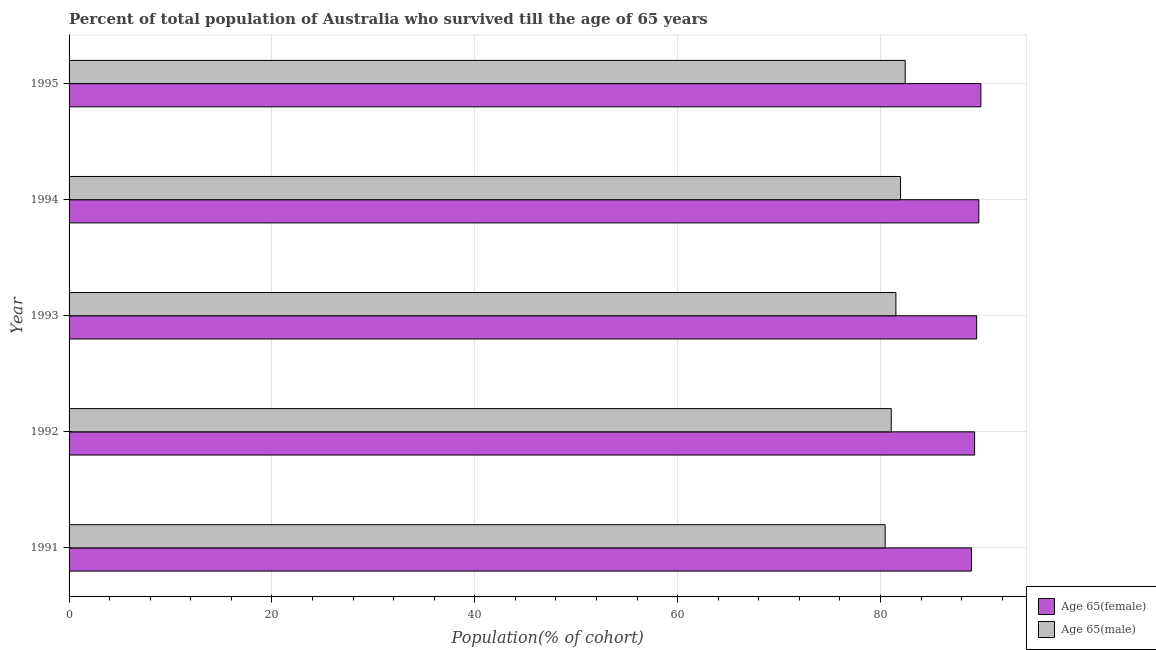How many groups of bars are there?
Provide a short and direct response. 5. Are the number of bars per tick equal to the number of legend labels?
Provide a succinct answer. Yes. Are the number of bars on each tick of the Y-axis equal?
Ensure brevity in your answer.  Yes. What is the label of the 3rd group of bars from the top?
Your answer should be very brief. 1993. What is the percentage of male population who survived till age of 65 in 1993?
Provide a short and direct response. 81.52. Across all years, what is the maximum percentage of female population who survived till age of 65?
Keep it short and to the point. 89.9. Across all years, what is the minimum percentage of male population who survived till age of 65?
Your response must be concise. 80.46. What is the total percentage of male population who survived till age of 65 in the graph?
Ensure brevity in your answer.  407.48. What is the difference between the percentage of male population who survived till age of 65 in 1991 and that in 1994?
Offer a terse response. -1.52. What is the difference between the percentage of female population who survived till age of 65 in 1994 and the percentage of male population who survived till age of 65 in 1991?
Provide a short and direct response. 9.23. What is the average percentage of female population who survived till age of 65 per year?
Your answer should be compact. 89.47. In the year 1991, what is the difference between the percentage of female population who survived till age of 65 and percentage of male population who survived till age of 65?
Provide a short and direct response. 8.5. What is the ratio of the percentage of female population who survived till age of 65 in 1992 to that in 1994?
Give a very brief answer. 0.99. What is the difference between the highest and the second highest percentage of female population who survived till age of 65?
Your answer should be very brief. 0.21. What is the difference between the highest and the lowest percentage of male population who survived till age of 65?
Give a very brief answer. 1.98. Is the sum of the percentage of female population who survived till age of 65 in 1991 and 1995 greater than the maximum percentage of male population who survived till age of 65 across all years?
Offer a terse response. Yes. What does the 2nd bar from the top in 1991 represents?
Provide a succinct answer. Age 65(female). What does the 1st bar from the bottom in 1993 represents?
Provide a short and direct response. Age 65(female). How many bars are there?
Keep it short and to the point. 10. Are all the bars in the graph horizontal?
Ensure brevity in your answer.  Yes. What is the difference between two consecutive major ticks on the X-axis?
Your answer should be very brief. 20. Are the values on the major ticks of X-axis written in scientific E-notation?
Give a very brief answer. No. Does the graph contain any zero values?
Make the answer very short. No. Where does the legend appear in the graph?
Provide a short and direct response. Bottom right. How are the legend labels stacked?
Offer a terse response. Vertical. What is the title of the graph?
Your answer should be very brief. Percent of total population of Australia who survived till the age of 65 years. What is the label or title of the X-axis?
Provide a short and direct response. Population(% of cohort). What is the Population(% of cohort) in Age 65(female) in 1991?
Keep it short and to the point. 88.97. What is the Population(% of cohort) in Age 65(male) in 1991?
Give a very brief answer. 80.46. What is the Population(% of cohort) in Age 65(female) in 1992?
Offer a terse response. 89.28. What is the Population(% of cohort) of Age 65(male) in 1992?
Keep it short and to the point. 81.07. What is the Population(% of cohort) in Age 65(female) in 1993?
Offer a terse response. 89.49. What is the Population(% of cohort) of Age 65(male) in 1993?
Your response must be concise. 81.52. What is the Population(% of cohort) in Age 65(female) in 1994?
Make the answer very short. 89.7. What is the Population(% of cohort) of Age 65(male) in 1994?
Keep it short and to the point. 81.98. What is the Population(% of cohort) of Age 65(female) in 1995?
Your answer should be compact. 89.9. What is the Population(% of cohort) in Age 65(male) in 1995?
Offer a very short reply. 82.44. Across all years, what is the maximum Population(% of cohort) of Age 65(female)?
Make the answer very short. 89.9. Across all years, what is the maximum Population(% of cohort) of Age 65(male)?
Your answer should be compact. 82.44. Across all years, what is the minimum Population(% of cohort) in Age 65(female)?
Your answer should be very brief. 88.97. Across all years, what is the minimum Population(% of cohort) in Age 65(male)?
Make the answer very short. 80.46. What is the total Population(% of cohort) of Age 65(female) in the graph?
Make the answer very short. 447.34. What is the total Population(% of cohort) in Age 65(male) in the graph?
Make the answer very short. 407.48. What is the difference between the Population(% of cohort) of Age 65(female) in 1991 and that in 1992?
Provide a short and direct response. -0.32. What is the difference between the Population(% of cohort) of Age 65(male) in 1991 and that in 1992?
Ensure brevity in your answer.  -0.6. What is the difference between the Population(% of cohort) in Age 65(female) in 1991 and that in 1993?
Provide a succinct answer. -0.52. What is the difference between the Population(% of cohort) in Age 65(male) in 1991 and that in 1993?
Your answer should be very brief. -1.06. What is the difference between the Population(% of cohort) of Age 65(female) in 1991 and that in 1994?
Offer a terse response. -0.73. What is the difference between the Population(% of cohort) of Age 65(male) in 1991 and that in 1994?
Make the answer very short. -1.52. What is the difference between the Population(% of cohort) in Age 65(female) in 1991 and that in 1995?
Your answer should be compact. -0.93. What is the difference between the Population(% of cohort) in Age 65(male) in 1991 and that in 1995?
Keep it short and to the point. -1.98. What is the difference between the Population(% of cohort) of Age 65(female) in 1992 and that in 1993?
Offer a very short reply. -0.21. What is the difference between the Population(% of cohort) in Age 65(male) in 1992 and that in 1993?
Make the answer very short. -0.46. What is the difference between the Population(% of cohort) of Age 65(female) in 1992 and that in 1994?
Keep it short and to the point. -0.41. What is the difference between the Population(% of cohort) in Age 65(male) in 1992 and that in 1994?
Provide a succinct answer. -0.92. What is the difference between the Population(% of cohort) in Age 65(female) in 1992 and that in 1995?
Your response must be concise. -0.62. What is the difference between the Population(% of cohort) of Age 65(male) in 1992 and that in 1995?
Your answer should be very brief. -1.37. What is the difference between the Population(% of cohort) of Age 65(female) in 1993 and that in 1994?
Ensure brevity in your answer.  -0.21. What is the difference between the Population(% of cohort) of Age 65(male) in 1993 and that in 1994?
Provide a succinct answer. -0.46. What is the difference between the Population(% of cohort) in Age 65(female) in 1993 and that in 1995?
Offer a terse response. -0.41. What is the difference between the Population(% of cohort) of Age 65(male) in 1993 and that in 1995?
Your response must be concise. -0.92. What is the difference between the Population(% of cohort) of Age 65(female) in 1994 and that in 1995?
Offer a terse response. -0.21. What is the difference between the Population(% of cohort) in Age 65(male) in 1994 and that in 1995?
Ensure brevity in your answer.  -0.46. What is the difference between the Population(% of cohort) in Age 65(female) in 1991 and the Population(% of cohort) in Age 65(male) in 1992?
Provide a short and direct response. 7.9. What is the difference between the Population(% of cohort) of Age 65(female) in 1991 and the Population(% of cohort) of Age 65(male) in 1993?
Give a very brief answer. 7.44. What is the difference between the Population(% of cohort) in Age 65(female) in 1991 and the Population(% of cohort) in Age 65(male) in 1994?
Keep it short and to the point. 6.99. What is the difference between the Population(% of cohort) of Age 65(female) in 1991 and the Population(% of cohort) of Age 65(male) in 1995?
Offer a terse response. 6.53. What is the difference between the Population(% of cohort) in Age 65(female) in 1992 and the Population(% of cohort) in Age 65(male) in 1993?
Offer a terse response. 7.76. What is the difference between the Population(% of cohort) of Age 65(female) in 1992 and the Population(% of cohort) of Age 65(male) in 1994?
Offer a very short reply. 7.3. What is the difference between the Population(% of cohort) of Age 65(female) in 1992 and the Population(% of cohort) of Age 65(male) in 1995?
Your response must be concise. 6.84. What is the difference between the Population(% of cohort) of Age 65(female) in 1993 and the Population(% of cohort) of Age 65(male) in 1994?
Your answer should be compact. 7.51. What is the difference between the Population(% of cohort) in Age 65(female) in 1993 and the Population(% of cohort) in Age 65(male) in 1995?
Make the answer very short. 7.05. What is the difference between the Population(% of cohort) in Age 65(female) in 1994 and the Population(% of cohort) in Age 65(male) in 1995?
Provide a succinct answer. 7.26. What is the average Population(% of cohort) of Age 65(female) per year?
Offer a terse response. 89.47. What is the average Population(% of cohort) in Age 65(male) per year?
Offer a very short reply. 81.5. In the year 1991, what is the difference between the Population(% of cohort) of Age 65(female) and Population(% of cohort) of Age 65(male)?
Provide a short and direct response. 8.5. In the year 1992, what is the difference between the Population(% of cohort) of Age 65(female) and Population(% of cohort) of Age 65(male)?
Keep it short and to the point. 8.22. In the year 1993, what is the difference between the Population(% of cohort) of Age 65(female) and Population(% of cohort) of Age 65(male)?
Your answer should be compact. 7.97. In the year 1994, what is the difference between the Population(% of cohort) of Age 65(female) and Population(% of cohort) of Age 65(male)?
Provide a succinct answer. 7.71. In the year 1995, what is the difference between the Population(% of cohort) in Age 65(female) and Population(% of cohort) in Age 65(male)?
Your response must be concise. 7.46. What is the ratio of the Population(% of cohort) of Age 65(female) in 1991 to that in 1992?
Your answer should be very brief. 1. What is the ratio of the Population(% of cohort) in Age 65(male) in 1991 to that in 1992?
Offer a terse response. 0.99. What is the ratio of the Population(% of cohort) of Age 65(male) in 1991 to that in 1993?
Give a very brief answer. 0.99. What is the ratio of the Population(% of cohort) in Age 65(male) in 1991 to that in 1994?
Your response must be concise. 0.98. What is the ratio of the Population(% of cohort) in Age 65(female) in 1991 to that in 1995?
Your answer should be compact. 0.99. What is the ratio of the Population(% of cohort) in Age 65(male) in 1991 to that in 1995?
Your answer should be compact. 0.98. What is the ratio of the Population(% of cohort) in Age 65(male) in 1992 to that in 1993?
Ensure brevity in your answer.  0.99. What is the ratio of the Population(% of cohort) of Age 65(male) in 1992 to that in 1994?
Make the answer very short. 0.99. What is the ratio of the Population(% of cohort) of Age 65(female) in 1992 to that in 1995?
Your response must be concise. 0.99. What is the ratio of the Population(% of cohort) of Age 65(male) in 1992 to that in 1995?
Give a very brief answer. 0.98. What is the ratio of the Population(% of cohort) in Age 65(female) in 1993 to that in 1994?
Your answer should be very brief. 1. What is the ratio of the Population(% of cohort) of Age 65(male) in 1993 to that in 1995?
Your response must be concise. 0.99. What is the ratio of the Population(% of cohort) in Age 65(male) in 1994 to that in 1995?
Give a very brief answer. 0.99. What is the difference between the highest and the second highest Population(% of cohort) in Age 65(female)?
Provide a short and direct response. 0.21. What is the difference between the highest and the second highest Population(% of cohort) of Age 65(male)?
Your response must be concise. 0.46. What is the difference between the highest and the lowest Population(% of cohort) of Age 65(female)?
Offer a very short reply. 0.93. What is the difference between the highest and the lowest Population(% of cohort) of Age 65(male)?
Your answer should be very brief. 1.98. 